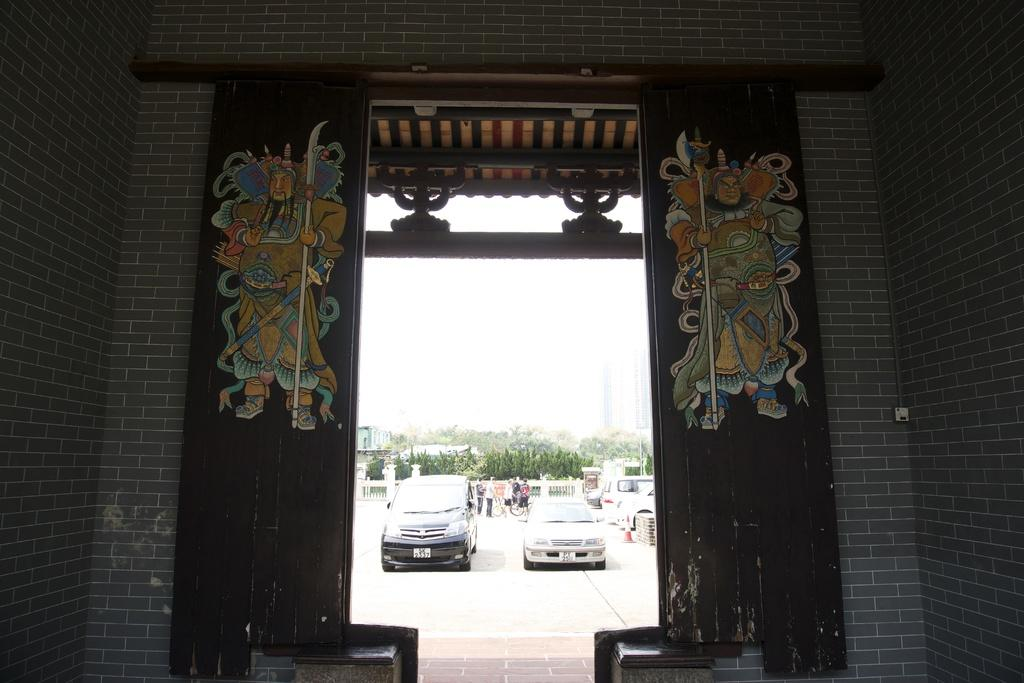What is the main structure in the center of the image? There is a wall with a door in the center of the image. What decorations are on the wall and door? There are paintings on the wall and door. What can be seen in the background of the image? The sky, trees, vehicles, and people are visible in the background of the image. Are there any other objects in the background of the image? Yes, there are other objects in the background of the image. What time of day is depicted in the afternoon scene in the image? There is no specific time of day mentioned or depicted in the image, nor is there a scene with an afternoon setting. 